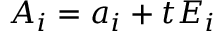Convert formula to latex. <formula><loc_0><loc_0><loc_500><loc_500>A _ { i } = a _ { i } + t E _ { i }</formula> 